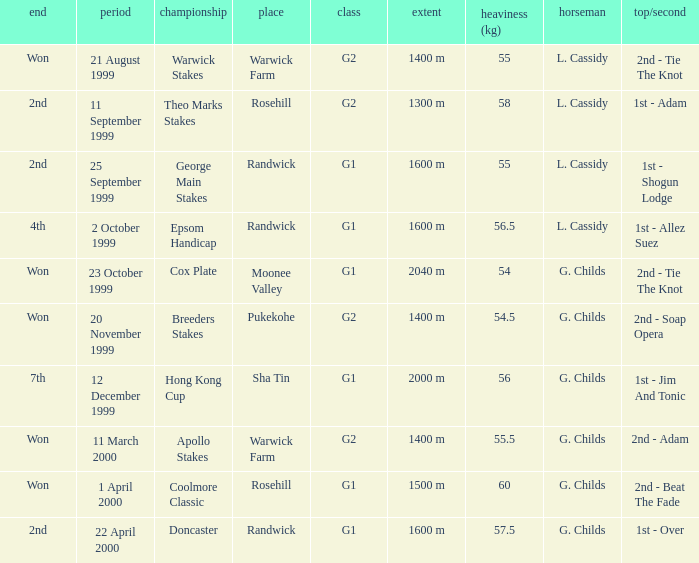How man teams had a total weight of 57.5? 1.0. 